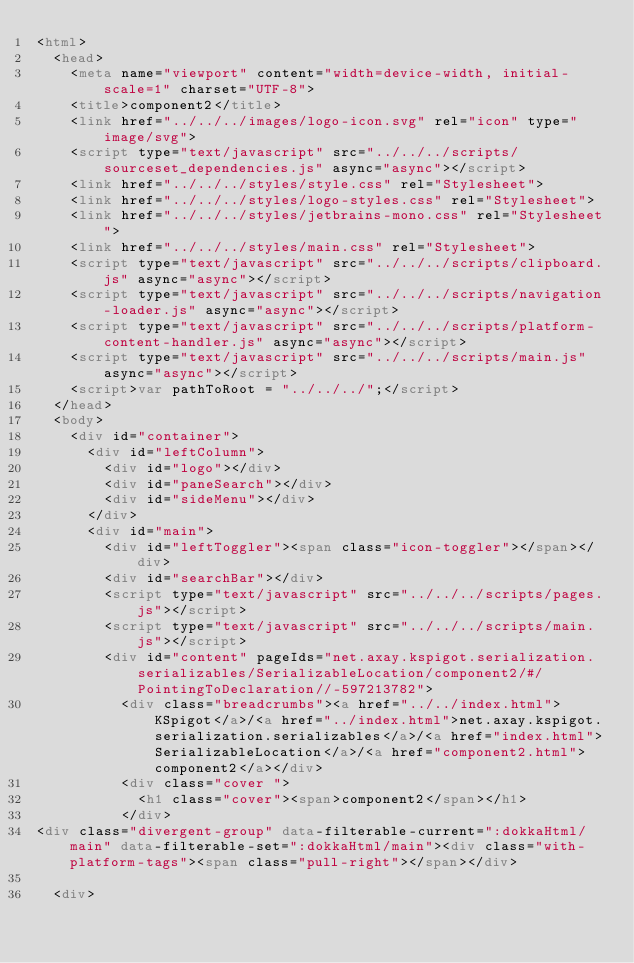Convert code to text. <code><loc_0><loc_0><loc_500><loc_500><_HTML_><html>
  <head>
    <meta name="viewport" content="width=device-width, initial-scale=1" charset="UTF-8">
    <title>component2</title>
    <link href="../../../images/logo-icon.svg" rel="icon" type="image/svg">
    <script type="text/javascript" src="../../../scripts/sourceset_dependencies.js" async="async"></script>
    <link href="../../../styles/style.css" rel="Stylesheet">
    <link href="../../../styles/logo-styles.css" rel="Stylesheet">
    <link href="../../../styles/jetbrains-mono.css" rel="Stylesheet">
    <link href="../../../styles/main.css" rel="Stylesheet">
    <script type="text/javascript" src="../../../scripts/clipboard.js" async="async"></script>
    <script type="text/javascript" src="../../../scripts/navigation-loader.js" async="async"></script>
    <script type="text/javascript" src="../../../scripts/platform-content-handler.js" async="async"></script>
    <script type="text/javascript" src="../../../scripts/main.js" async="async"></script>
    <script>var pathToRoot = "../../../";</script>
  </head>
  <body>
    <div id="container">
      <div id="leftColumn">
        <div id="logo"></div>
        <div id="paneSearch"></div>
        <div id="sideMenu"></div>
      </div>
      <div id="main">
        <div id="leftToggler"><span class="icon-toggler"></span></div>
        <div id="searchBar"></div>
        <script type="text/javascript" src="../../../scripts/pages.js"></script>
        <script type="text/javascript" src="../../../scripts/main.js"></script>
        <div id="content" pageIds="net.axay.kspigot.serialization.serializables/SerializableLocation/component2/#/PointingToDeclaration//-597213782">
          <div class="breadcrumbs"><a href="../../index.html">KSpigot</a>/<a href="../index.html">net.axay.kspigot.serialization.serializables</a>/<a href="index.html">SerializableLocation</a>/<a href="component2.html">component2</a></div>
          <div class="cover ">
            <h1 class="cover"><span>component2</span></h1>
          </div>
<div class="divergent-group" data-filterable-current=":dokkaHtml/main" data-filterable-set=":dokkaHtml/main"><div class="with-platform-tags"><span class="pull-right"></span></div>

  <div></code> 